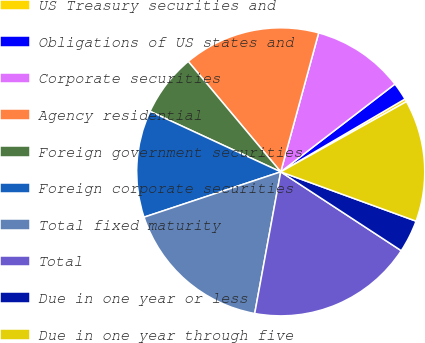Convert chart to OTSL. <chart><loc_0><loc_0><loc_500><loc_500><pie_chart><fcel>US Treasury securities and<fcel>Obligations of US states and<fcel>Corporate securities<fcel>Agency residential<fcel>Foreign government securities<fcel>Foreign corporate securities<fcel>Total fixed maturity<fcel>Total<fcel>Due in one year or less<fcel>Due in one year through five<nl><fcel>0.33%<fcel>1.99%<fcel>10.33%<fcel>15.34%<fcel>7.0%<fcel>12.0%<fcel>17.01%<fcel>18.67%<fcel>3.66%<fcel>13.67%<nl></chart> 